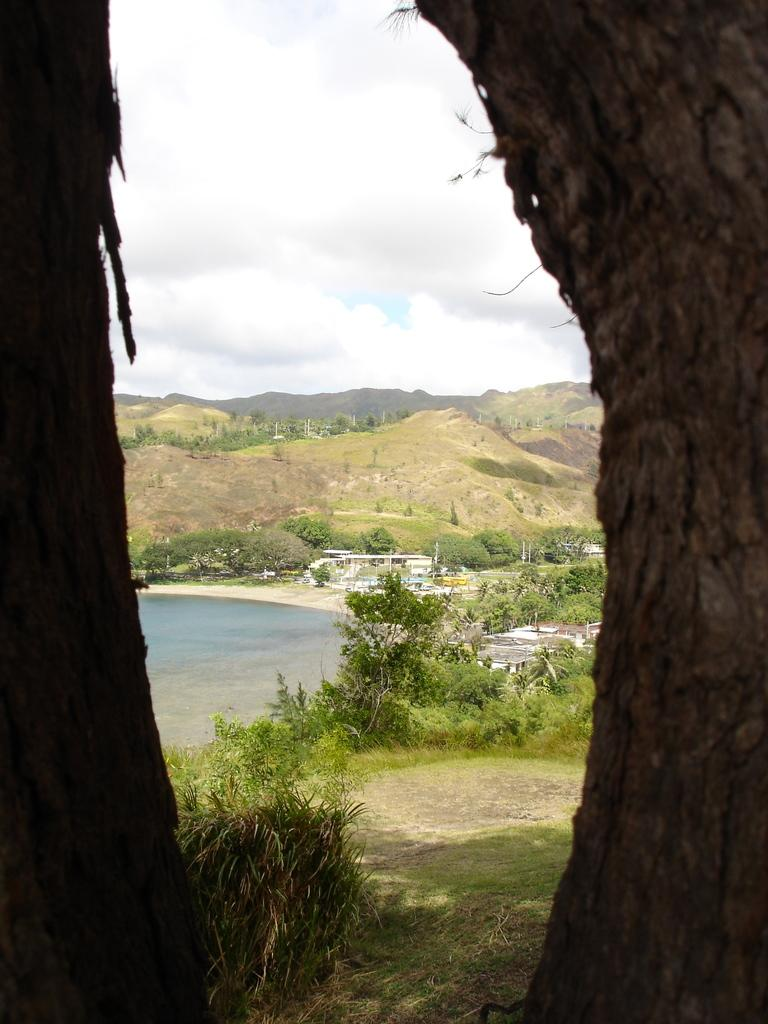What can be seen on both sides of the image? There are tree trunks on both sides of the image. What type of vegetation is visible in the background of the image? There are plants and trees in the background of the image. What natural feature can be seen in the background of the image? There is water visible in the background of the image. What type of landscape is visible in the background of the image? There are hills in the background of the image. What is visible in the sky in the background of the image? The sky is visible in the background of the image, and clouds are present. How many pizzas are being eaten by the boy in the image? There is no boy or pizzas present in the image. What type of fang can be seen on the tree trunks in the image? There are no fangs present on the tree trunks in the image; they are simply tree trunks. 